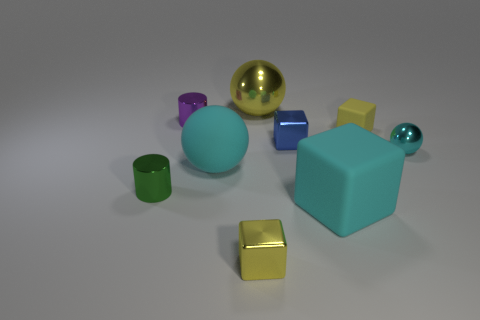Subtract all cyan spheres. How many spheres are left? 1 Add 1 large objects. How many objects exist? 10 Subtract all yellow balls. How many balls are left? 2 Subtract all cyan cylinders. How many brown blocks are left? 0 Subtract all cylinders. How many objects are left? 7 Subtract 2 cylinders. How many cylinders are left? 0 Add 8 big balls. How many big balls are left? 10 Add 2 large matte cubes. How many large matte cubes exist? 3 Subtract 0 purple balls. How many objects are left? 9 Subtract all blue cubes. Subtract all red cylinders. How many cubes are left? 3 